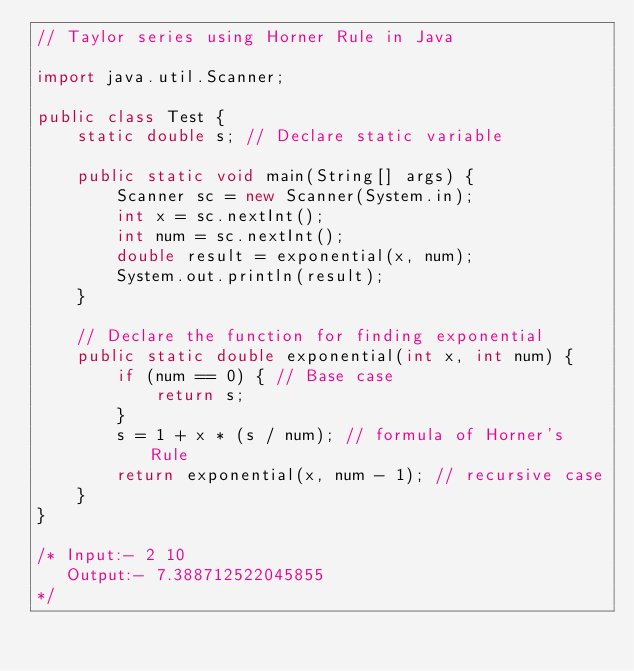Convert code to text. <code><loc_0><loc_0><loc_500><loc_500><_Java_>// Taylor series using Horner Rule in Java

import java.util.Scanner;

public class Test {
    static double s; // Declare static variable
    
    public static void main(String[] args) {
        Scanner sc = new Scanner(System.in);
        int x = sc.nextInt();
        int num = sc.nextInt();
        double result = exponential(x, num);
        System.out.println(result);
    }

    // Declare the function for finding exponential
    public static double exponential(int x, int num) {
        if (num == 0) { // Base case
            return s;
        }
        s = 1 + x * (s / num); // formula of Horner's Rule
        return exponential(x, num - 1); // recursive case
    }
}

/* Input:- 2 10
   Output:- 7.388712522045855
*/
</code> 